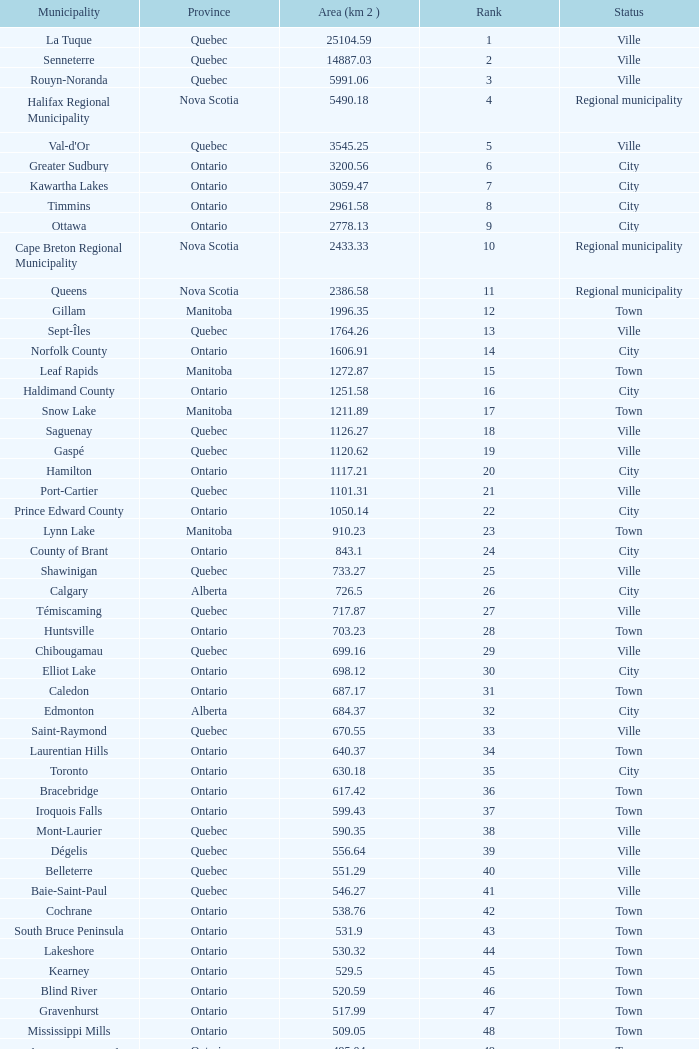What is the highest Area (KM 2) for the Province of Ontario, that has the Status of Town, a Municipality of Minto, and a Rank that's smaller than 84? None. Write the full table. {'header': ['Municipality', 'Province', 'Area (km 2 )', 'Rank', 'Status'], 'rows': [['La Tuque', 'Quebec', '25104.59', '1', 'Ville'], ['Senneterre', 'Quebec', '14887.03', '2', 'Ville'], ['Rouyn-Noranda', 'Quebec', '5991.06', '3', 'Ville'], ['Halifax Regional Municipality', 'Nova Scotia', '5490.18', '4', 'Regional municipality'], ["Val-d'Or", 'Quebec', '3545.25', '5', 'Ville'], ['Greater Sudbury', 'Ontario', '3200.56', '6', 'City'], ['Kawartha Lakes', 'Ontario', '3059.47', '7', 'City'], ['Timmins', 'Ontario', '2961.58', '8', 'City'], ['Ottawa', 'Ontario', '2778.13', '9', 'City'], ['Cape Breton Regional Municipality', 'Nova Scotia', '2433.33', '10', 'Regional municipality'], ['Queens', 'Nova Scotia', '2386.58', '11', 'Regional municipality'], ['Gillam', 'Manitoba', '1996.35', '12', 'Town'], ['Sept-Îles', 'Quebec', '1764.26', '13', 'Ville'], ['Norfolk County', 'Ontario', '1606.91', '14', 'City'], ['Leaf Rapids', 'Manitoba', '1272.87', '15', 'Town'], ['Haldimand County', 'Ontario', '1251.58', '16', 'City'], ['Snow Lake', 'Manitoba', '1211.89', '17', 'Town'], ['Saguenay', 'Quebec', '1126.27', '18', 'Ville'], ['Gaspé', 'Quebec', '1120.62', '19', 'Ville'], ['Hamilton', 'Ontario', '1117.21', '20', 'City'], ['Port-Cartier', 'Quebec', '1101.31', '21', 'Ville'], ['Prince Edward County', 'Ontario', '1050.14', '22', 'City'], ['Lynn Lake', 'Manitoba', '910.23', '23', 'Town'], ['County of Brant', 'Ontario', '843.1', '24', 'City'], ['Shawinigan', 'Quebec', '733.27', '25', 'Ville'], ['Calgary', 'Alberta', '726.5', '26', 'City'], ['Témiscaming', 'Quebec', '717.87', '27', 'Ville'], ['Huntsville', 'Ontario', '703.23', '28', 'Town'], ['Chibougamau', 'Quebec', '699.16', '29', 'Ville'], ['Elliot Lake', 'Ontario', '698.12', '30', 'City'], ['Caledon', 'Ontario', '687.17', '31', 'Town'], ['Edmonton', 'Alberta', '684.37', '32', 'City'], ['Saint-Raymond', 'Quebec', '670.55', '33', 'Ville'], ['Laurentian Hills', 'Ontario', '640.37', '34', 'Town'], ['Toronto', 'Ontario', '630.18', '35', 'City'], ['Bracebridge', 'Ontario', '617.42', '36', 'Town'], ['Iroquois Falls', 'Ontario', '599.43', '37', 'Town'], ['Mont-Laurier', 'Quebec', '590.35', '38', 'Ville'], ['Dégelis', 'Quebec', '556.64', '39', 'Ville'], ['Belleterre', 'Quebec', '551.29', '40', 'Ville'], ['Baie-Saint-Paul', 'Quebec', '546.27', '41', 'Ville'], ['Cochrane', 'Ontario', '538.76', '42', 'Town'], ['South Bruce Peninsula', 'Ontario', '531.9', '43', 'Town'], ['Lakeshore', 'Ontario', '530.32', '44', 'Town'], ['Kearney', 'Ontario', '529.5', '45', 'Town'], ['Blind River', 'Ontario', '520.59', '46', 'Town'], ['Gravenhurst', 'Ontario', '517.99', '47', 'Town'], ['Mississippi Mills', 'Ontario', '509.05', '48', 'Town'], ['Northeastern Manitoulin and the Islands', 'Ontario', '495.04', '49', 'Town'], ['Quinte West', 'Ontario', '493.85', '50', 'City'], ['Mirabel', 'Quebec', '485.51', '51', 'Ville'], ['Fermont', 'Quebec', '470.67', '52', 'Ville'], ['Winnipeg', 'Manitoba', '464.01', '53', 'City'], ['Greater Napanee', 'Ontario', '459.71', '54', 'Town'], ['La Malbaie', 'Quebec', '459.34', '55', 'Ville'], ['Rivière-Rouge', 'Quebec', '454.99', '56', 'Ville'], ['Québec City', 'Quebec', '454.26', '57', 'Ville'], ['Kingston', 'Ontario', '450.39', '58', 'City'], ['Lévis', 'Quebec', '449.32', '59', 'Ville'], ["St. John's", 'Newfoundland and Labrador', '446.04', '60', 'City'], ['Bécancour', 'Quebec', '441', '61', 'Ville'], ['Percé', 'Quebec', '432.39', '62', 'Ville'], ['Amos', 'Quebec', '430.06', '63', 'Ville'], ['London', 'Ontario', '420.57', '64', 'City'], ['Chandler', 'Quebec', '419.5', '65', 'Ville'], ['Whitehorse', 'Yukon', '416.43', '66', 'City'], ['Gracefield', 'Quebec', '386.21', '67', 'Ville'], ['Baie Verte', 'Newfoundland and Labrador', '371.07', '68', 'Town'], ['Milton', 'Ontario', '366.61', '69', 'Town'], ['Montreal', 'Quebec', '365.13', '70', 'Ville'], ['Saint-Félicien', 'Quebec', '363.57', '71', 'Ville'], ['Abbotsford', 'British Columbia', '359.36', '72', 'City'], ['Sherbrooke', 'Quebec', '353.46', '73', 'Ville'], ['Gatineau', 'Quebec', '342.32', '74', 'Ville'], ['Pohénégamook', 'Quebec', '340.33', '75', 'Ville'], ['Baie-Comeau', 'Quebec', '338.88', '76', 'Ville'], ['Thunder Bay', 'Ontario', '328.48', '77', 'City'], ['Plympton–Wyoming', 'Ontario', '318.76', '78', 'Town'], ['Surrey', 'British Columbia', '317.19', '79', 'City'], ['Prince George', 'British Columbia', '316', '80', 'City'], ['Saint John', 'New Brunswick', '315.49', '81', 'City'], ['North Bay', 'Ontario', '314.91', '82', 'City'], ['Happy Valley-Goose Bay', 'Newfoundland and Labrador', '305.85', '83', 'Town'], ['Minto', 'Ontario', '300.37', '84', 'Town'], ['Kamloops', 'British Columbia', '297.3', '85', 'City'], ['Erin', 'Ontario', '296.98', '86', 'Town'], ['Clarence-Rockland', 'Ontario', '296.53', '87', 'City'], ['Cookshire-Eaton', 'Quebec', '295.93', '88', 'Ville'], ['Dolbeau-Mistassini', 'Quebec', '295.67', '89', 'Ville'], ['Trois-Rivières', 'Quebec', '288.92', '90', 'Ville'], ['Mississauga', 'Ontario', '288.53', '91', 'City'], ['Georgina', 'Ontario', '287.72', '92', 'Town'], ['The Blue Mountains', 'Ontario', '286.78', '93', 'Town'], ['Innisfil', 'Ontario', '284.18', '94', 'Town'], ['Essex', 'Ontario', '277.95', '95', 'Town'], ['Mono', 'Ontario', '277.67', '96', 'Town'], ['Halton Hills', 'Ontario', '276.26', '97', 'Town'], ['New Tecumseth', 'Ontario', '274.18', '98', 'Town'], ['Vaughan', 'Ontario', '273.58', '99', 'City'], ['Brampton', 'Ontario', '266.71', '100', 'City']]} 